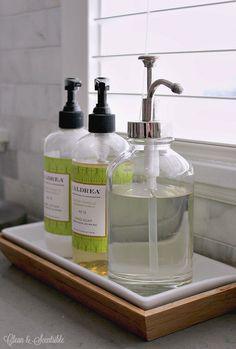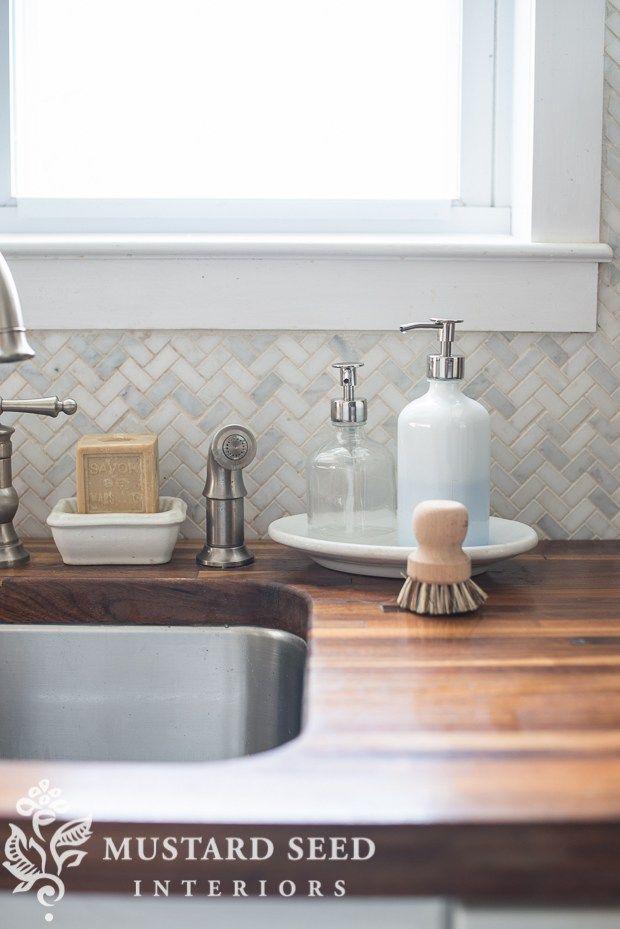The first image is the image on the left, the second image is the image on the right. Considering the images on both sides, is "There is blue liquid visible inside a clear soap dispenser" valid? Answer yes or no. No. The first image is the image on the left, the second image is the image on the right. For the images shown, is this caption "An image shows a pump dispenser containing a blue liquid." true? Answer yes or no. No. 